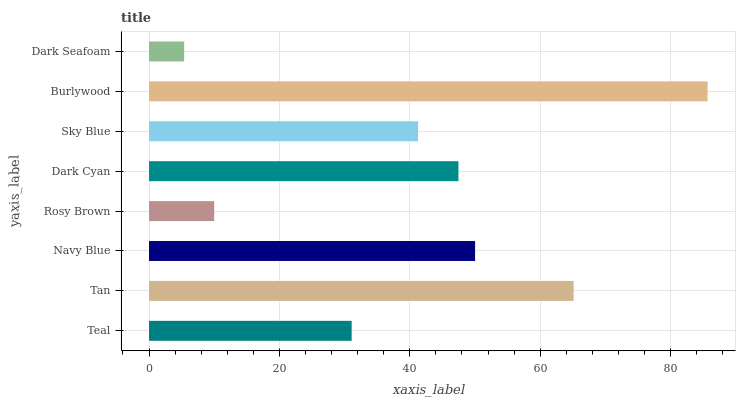Is Dark Seafoam the minimum?
Answer yes or no. Yes. Is Burlywood the maximum?
Answer yes or no. Yes. Is Tan the minimum?
Answer yes or no. No. Is Tan the maximum?
Answer yes or no. No. Is Tan greater than Teal?
Answer yes or no. Yes. Is Teal less than Tan?
Answer yes or no. Yes. Is Teal greater than Tan?
Answer yes or no. No. Is Tan less than Teal?
Answer yes or no. No. Is Dark Cyan the high median?
Answer yes or no. Yes. Is Sky Blue the low median?
Answer yes or no. Yes. Is Sky Blue the high median?
Answer yes or no. No. Is Dark Seafoam the low median?
Answer yes or no. No. 